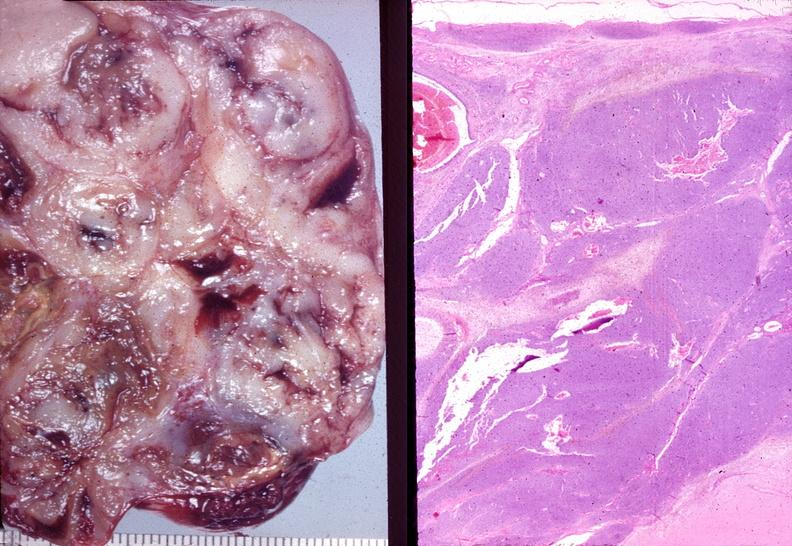does this image show ovary, granulosa cell tumor?
Answer the question using a single word or phrase. Yes 